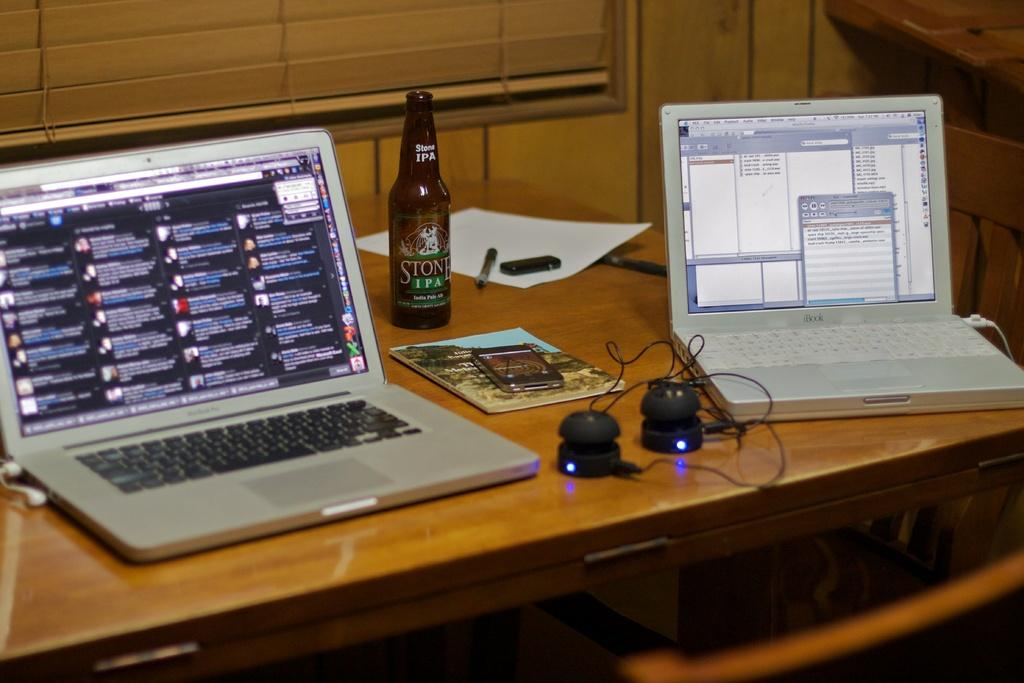How many laptops are on the table in the image? There are two laptops on the table in the image. What other electronic device is on the table? There is a mobile on the table. What type of accessory is on the table for listening to audio? There are headphones on the table. What non-electronic item can be seen on the table? There is a book on the table. What writing instrument is on the table? There is a pen on the table. What beverage container is on the table? There is a bottle on the table. How many tails are visible on the laptops in the image? There are no tails visible on the laptops in the image, as laptops do not have tails. What number is written on the book in the image? There is no number visible on the book in the image. 